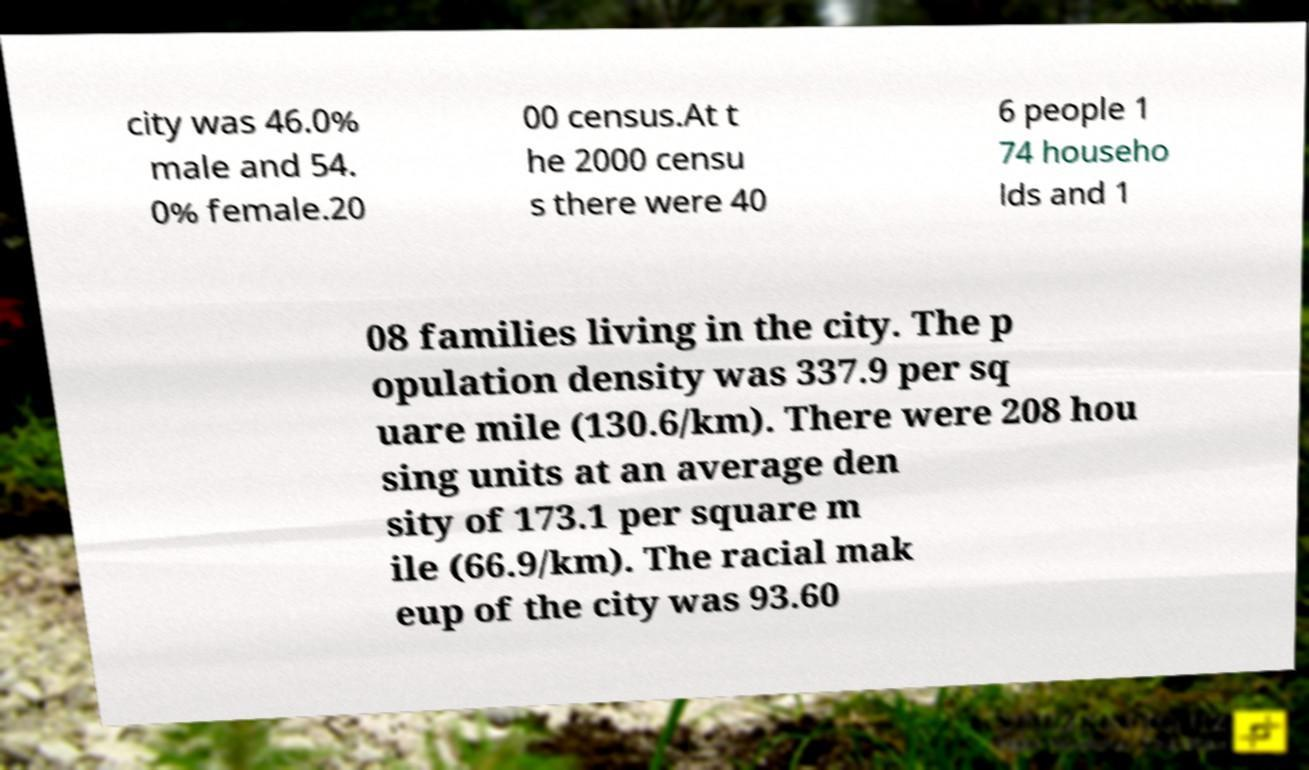Can you accurately transcribe the text from the provided image for me? city was 46.0% male and 54. 0% female.20 00 census.At t he 2000 censu s there were 40 6 people 1 74 househo lds and 1 08 families living in the city. The p opulation density was 337.9 per sq uare mile (130.6/km). There were 208 hou sing units at an average den sity of 173.1 per square m ile (66.9/km). The racial mak eup of the city was 93.60 